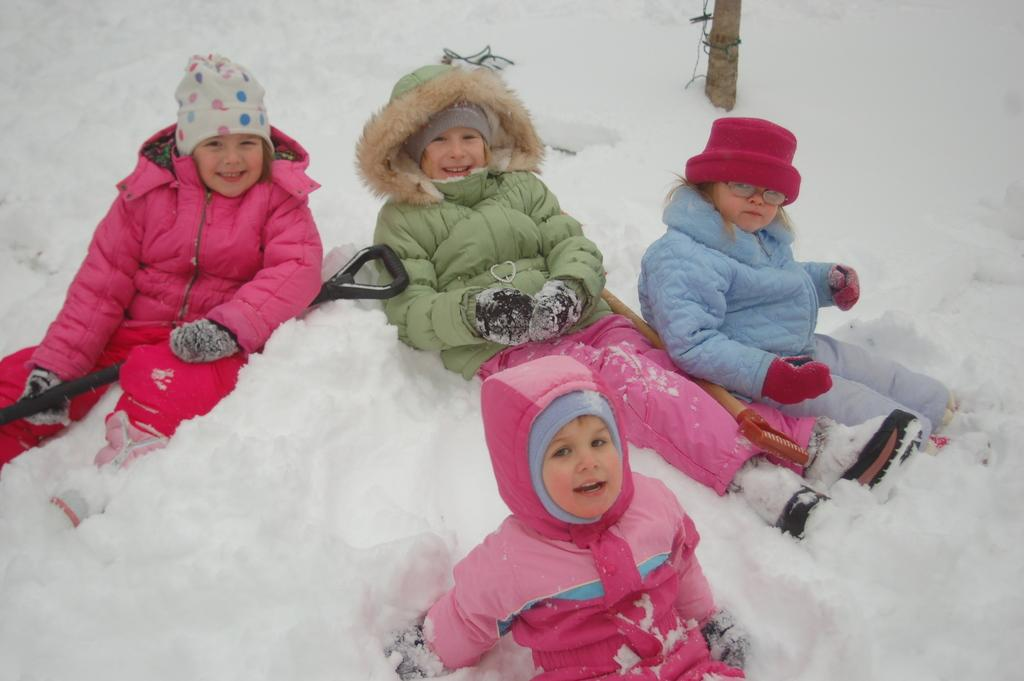Who is present in the image? There are kids in the image. What are the kids sitting on? The kids are sitting on the snow. What type of clothing are the kids wearing? The kids are wearing jackets and caps. What tools can be seen in the image? There are shovels visible in the image. Where is the crib located in the image? There is no crib present in the image. What is the temperature of the burn in the image? There is no burn present in the image. 